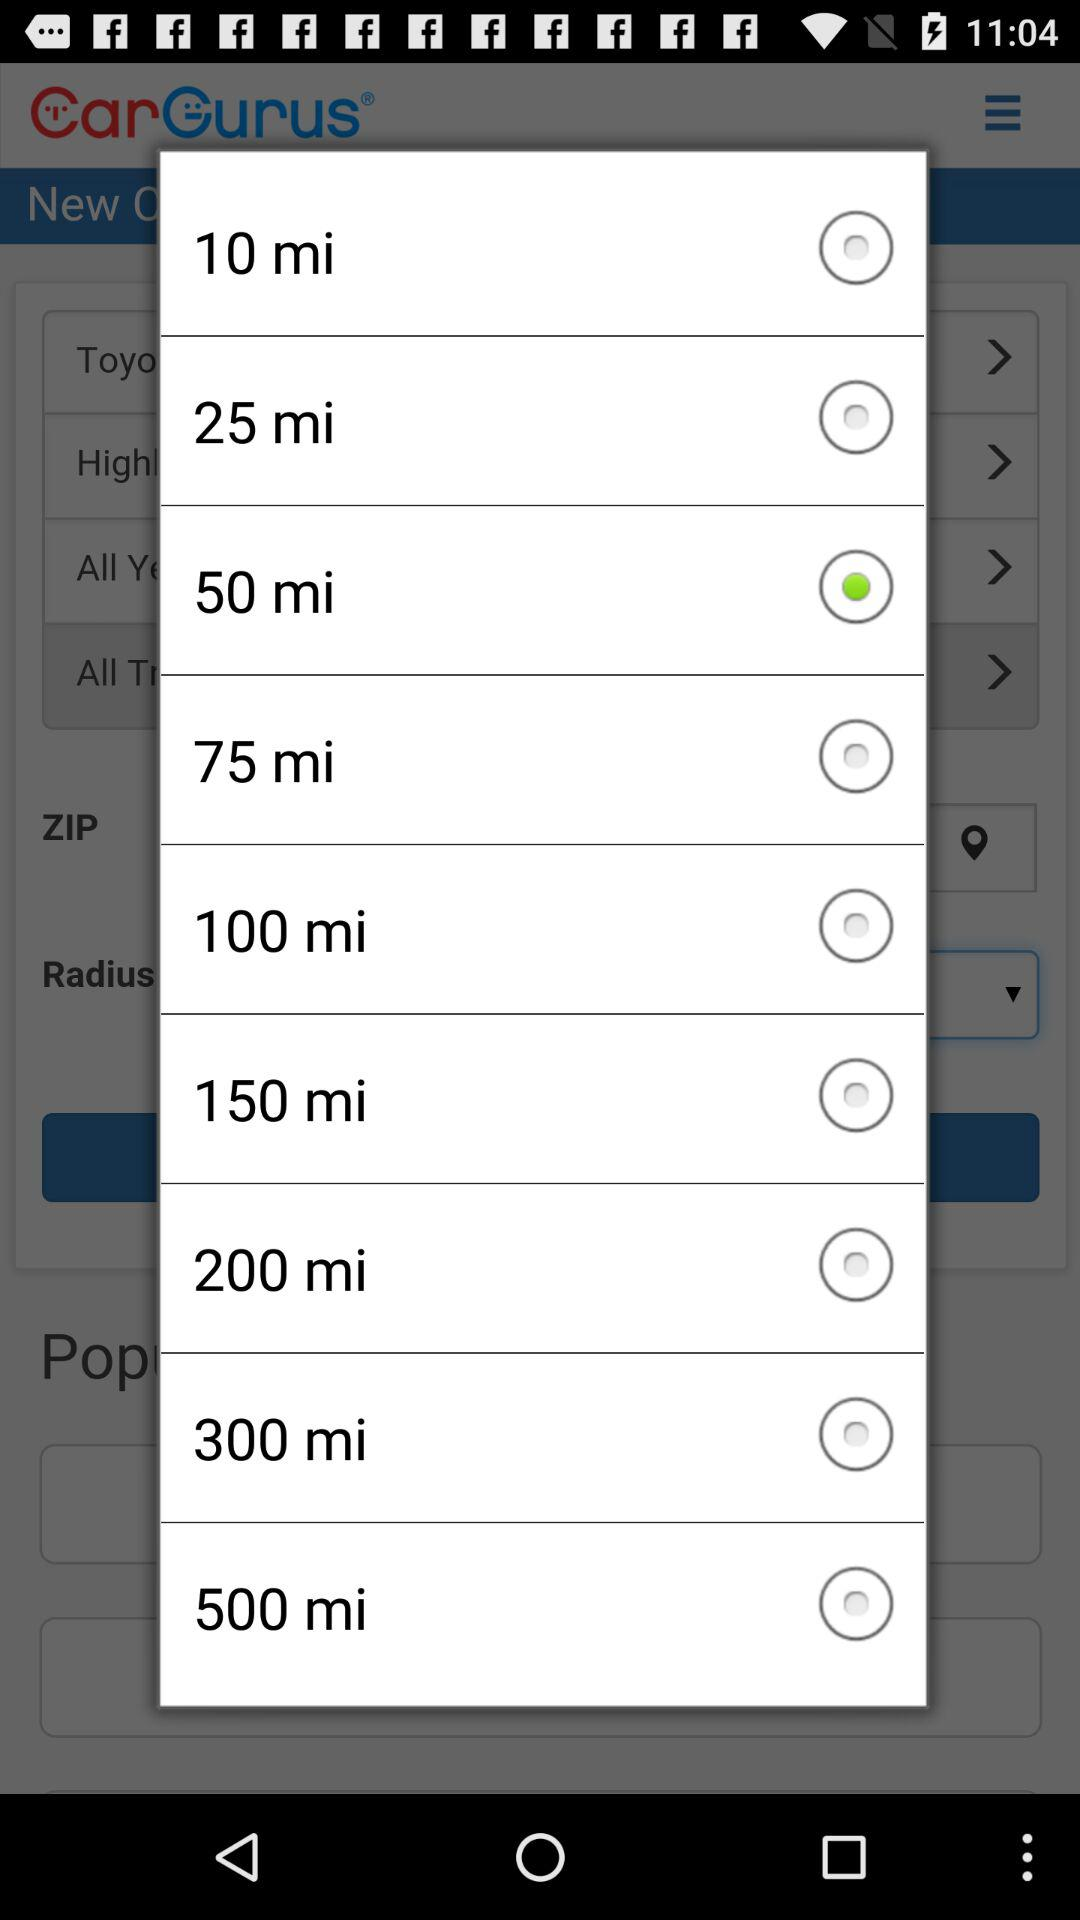Which option is selected? The selected option is "50 mi". 